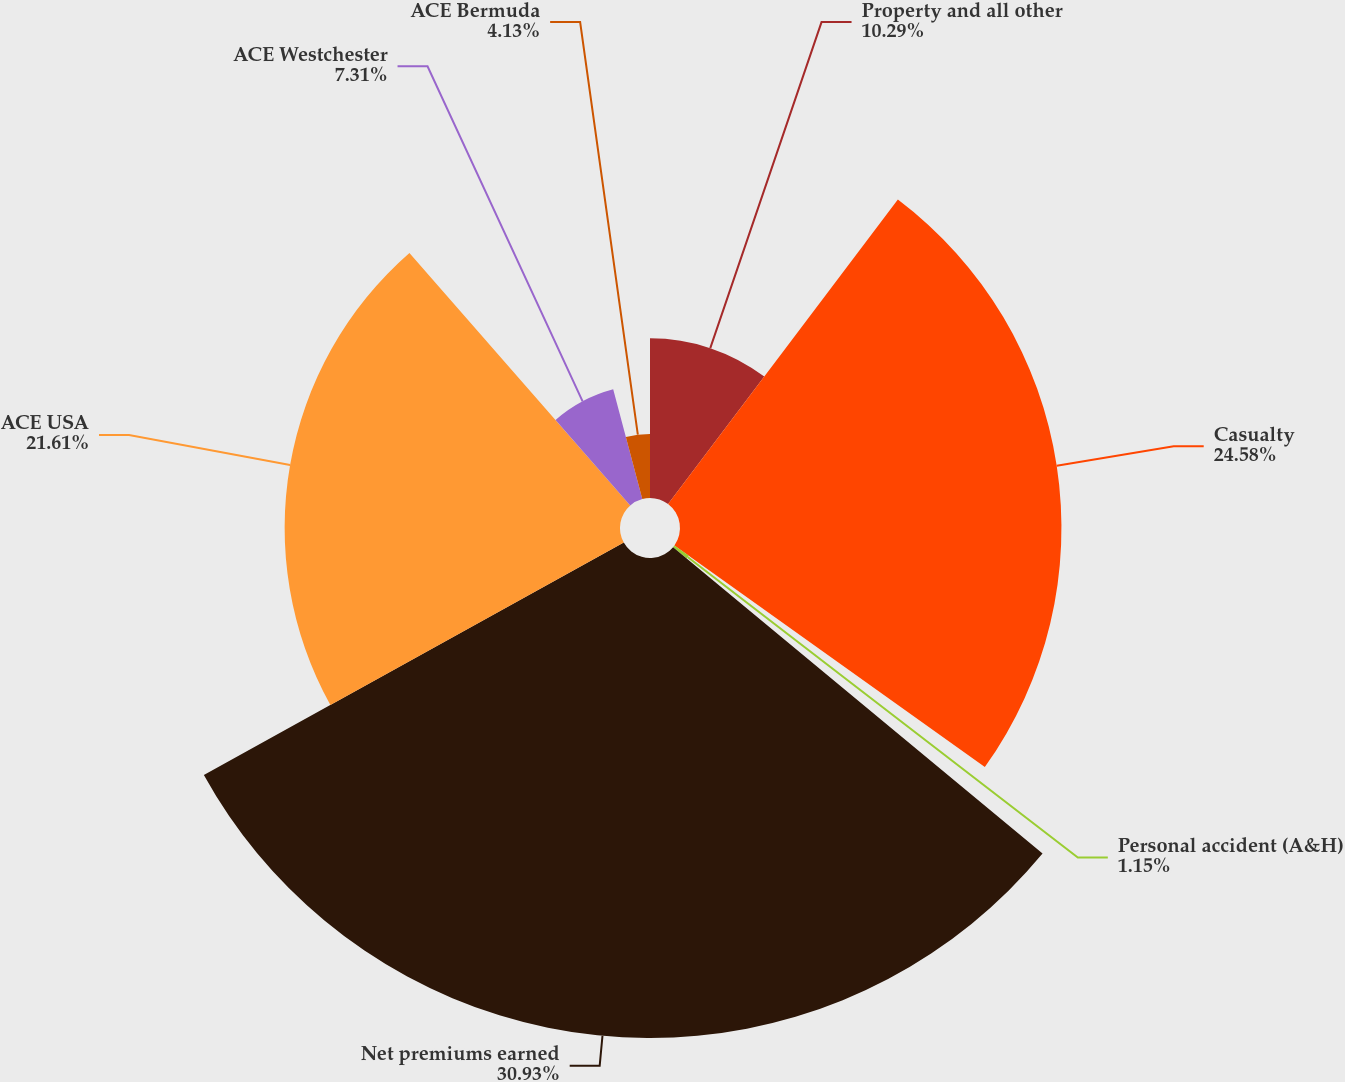Convert chart to OTSL. <chart><loc_0><loc_0><loc_500><loc_500><pie_chart><fcel>Property and all other<fcel>Casualty<fcel>Personal accident (A&H)<fcel>Net premiums earned<fcel>ACE USA<fcel>ACE Westchester<fcel>ACE Bermuda<nl><fcel>10.29%<fcel>24.58%<fcel>1.15%<fcel>30.93%<fcel>21.61%<fcel>7.31%<fcel>4.13%<nl></chart> 